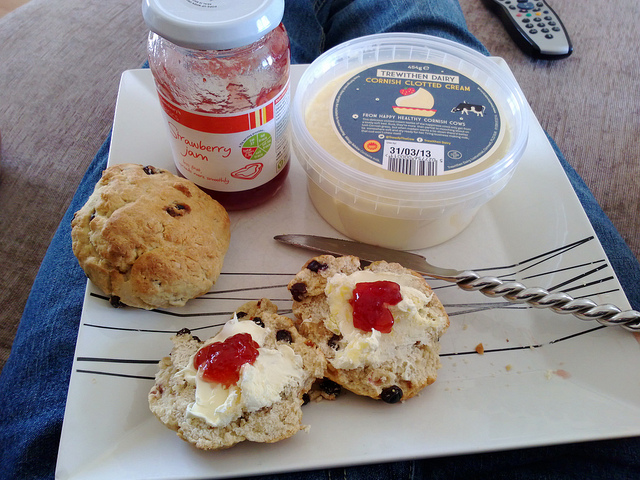Extract all visible text content from this image. jam JAM 31 13 CORNISH CLOTTED CREAM DAIRY THEWITHEN 03 